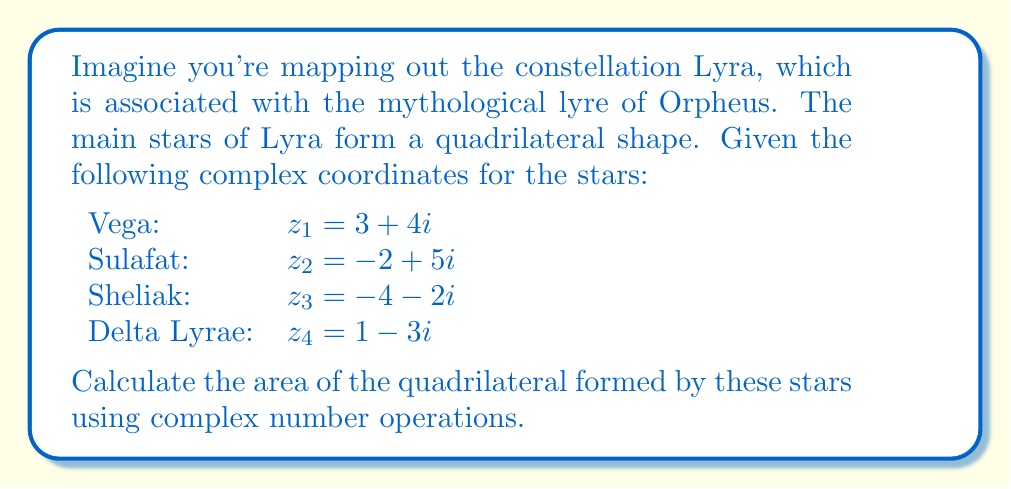Help me with this question. To find the area of a quadrilateral using complex numbers, we can use the following formula:

$$\text{Area} = \frac{1}{2}|\text{Im}(z_1\bar{z_2} + z_2\bar{z_3} + z_3\bar{z_4} + z_4\bar{z_1})|$$

Where $\bar{z}$ represents the complex conjugate of $z$, and Im() denotes the imaginary part.

Let's calculate each term:

1) $z_1\bar{z_2} = (3+4i)(-2-5i) = -6-15i-8i+20 = 14-23i$

2) $z_2\bar{z_3} = (-2+5i)(-4+2i) = 8-4i-20i-10 = -2-24i$

3) $z_3\bar{z_4} = (-4-2i)(1+3i) = -4-12i+2i-6 = -10-10i$

4) $z_4\bar{z_1} = (1-3i)(3-4i) = 3-12i+9i+12 = 15-3i$

Sum these up:
$$(14-23i) + (-2-24i) + (-10-10i) + (15-3i) = 17-60i$$

The imaginary part is -60.

Therefore, the area is:

$$\text{Area} = \frac{1}{2}|-60| = 30$$
Answer: The area of the quadrilateral formed by the main stars of the Lyra constellation is 30 square units. 